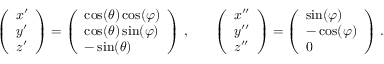Convert formula to latex. <formula><loc_0><loc_0><loc_500><loc_500>\begin{array} { r l r } { \left ( \begin{array} { l } { x ^ { \prime } } \\ { y ^ { \prime } } \\ { z ^ { \prime } } \end{array} \right ) = \left ( \begin{array} { l } { \cos ( \theta ) \cos ( \varphi ) } \\ { \cos ( \theta ) \sin ( \varphi ) } \\ { - \sin ( \theta ) } \end{array} \right ) \, , } & { \left ( \begin{array} { l } { x ^ { \prime \prime } } \\ { y ^ { \prime \prime } } \\ { z ^ { \prime \prime } } \end{array} \right ) = \left ( \begin{array} { l } { \sin ( \varphi ) } \\ { - \cos ( \varphi ) } \\ { 0 } \end{array} \right ) \, . } \end{array}</formula> 